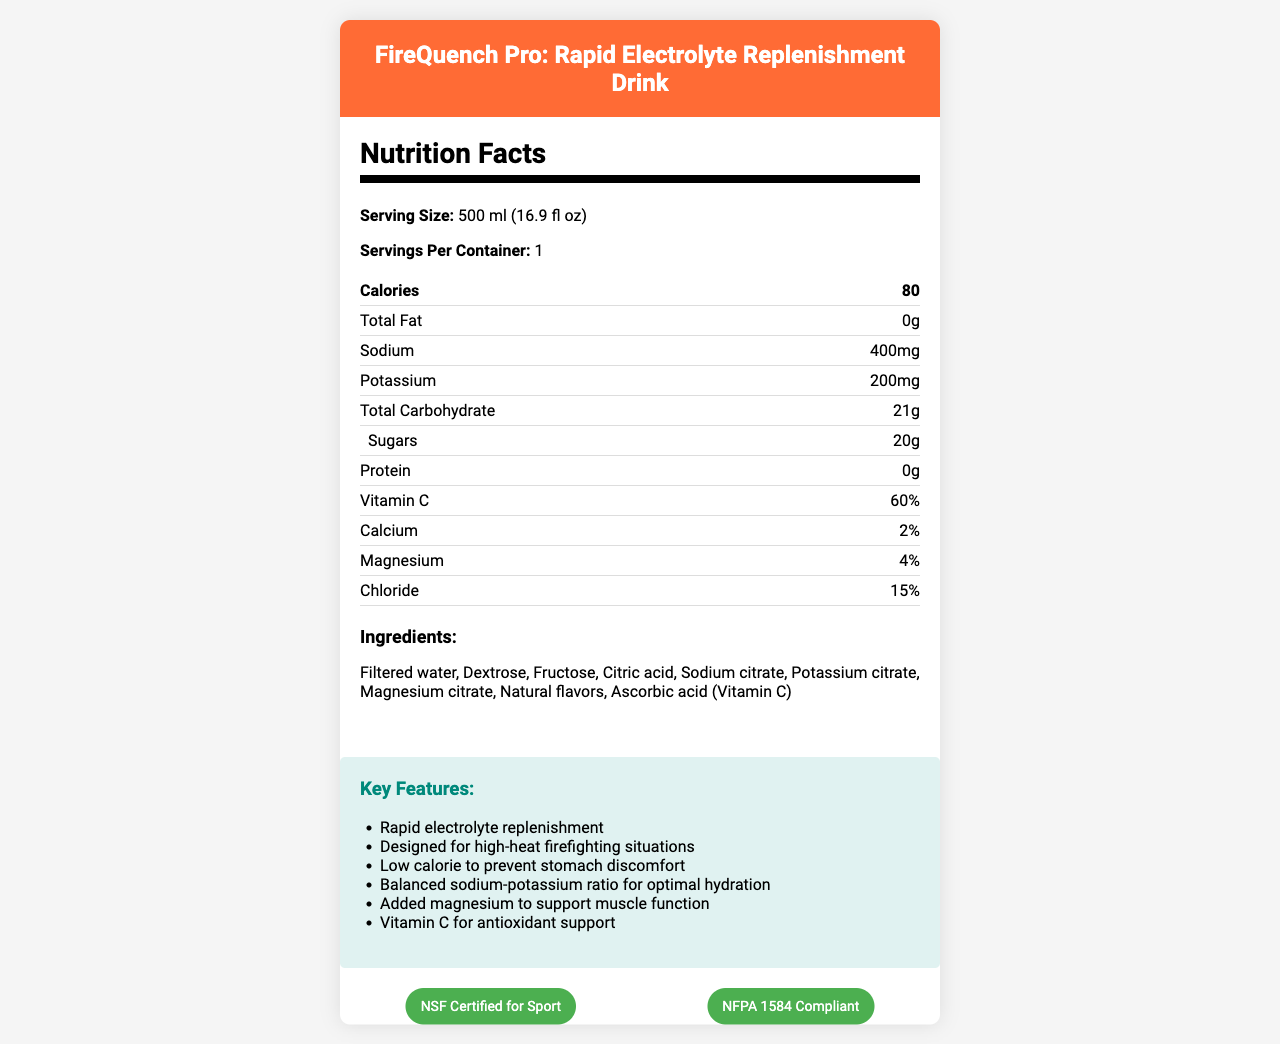what is the serving size? The serving size is directly mentioned at the beginning of the nutrition facts section.
Answer: 500 ml (16.9 fl oz) how many calories are in one serving? The calories per serving are listed in the nutrition facts section under the "Calories" label.
Answer: 80 what is the amount of sodium in the drink? The amount of sodium is provided in the nutrition facts section as "Sodium: 400 mg."
Answer: 400 mg list three key features of the product. These features are found under the "Key Features" section.
Answer: Rapid electrolyte replenishment, Designed for high-heat firefighting situations, Low calorie to prevent stomach discomfort what percentage of vitamin c is in the drink? The amount of Vitamin C is mentioned as "Vitamin C: 60%" in the nutrition facts section.
Answer: 60% what are the main ingredients of the hydration drink? The ingredients are listed under the "Ingredients" section.
Answer: Filtered water, Dextrose, Fructose, Citric acid, Sodium citrate, Potassium citrate, Magnesium citrate, Natural flavors, Ascorbic acid (Vitamin C) how many grams of sugar does the drink contain? The amount of sugar is detailed in the nutrition facts section as "Sugars: 20 g."
Answer: 20 grams what certifications does the product hold? A. NSF Certified for Sport B. ISO Certified C. NFPA 1584 Compliant D. FDA Approved The correct certifications listed in the document are "NSF Certified for Sport" and "NFPA 1584 Compliant."
Answer: A, C how should the drink be stored after opening? A. Store at room temperature B. Freeze immediately C. Refrigerate and consume within 24 hours According to the storage instructions, the drink should be refrigerated and consumed within 24 hours after opening.
Answer: C how many servings are in each container? A. 1 serving B. 2 servings C. 3 servings The document specifies that there is 1 serving per container.
Answer: A does the drink contain any fat? The nutrition facts section states "Total Fat: 0g", indicating that there is no fat in the drink.
Answer: No is FireQuench Pro certified by NSF? The document includes "NSF Certified for Sport" under its certifications.
Answer: True describe the main idea of the document. The main idea covers various sections including nutrition facts, key features, storage instructions, and certifications, showing the product's relevance and utility for firefighters.
Answer: The document provides the nutritional information, key features, ingredients, and certifications of the "FireQuench Pro: Rapid Electrolyte Replenishment Drink" designed for use in high-heat firefighting situations. It focuses on the drink's benefits for rapid hydration and muscle support while also detailing storage instructions and ingredient components. what is the caffeine content of the drink? The document does not provide information on the caffeine content, so this cannot be determined from the available visual data.
Answer: Cannot be determined 